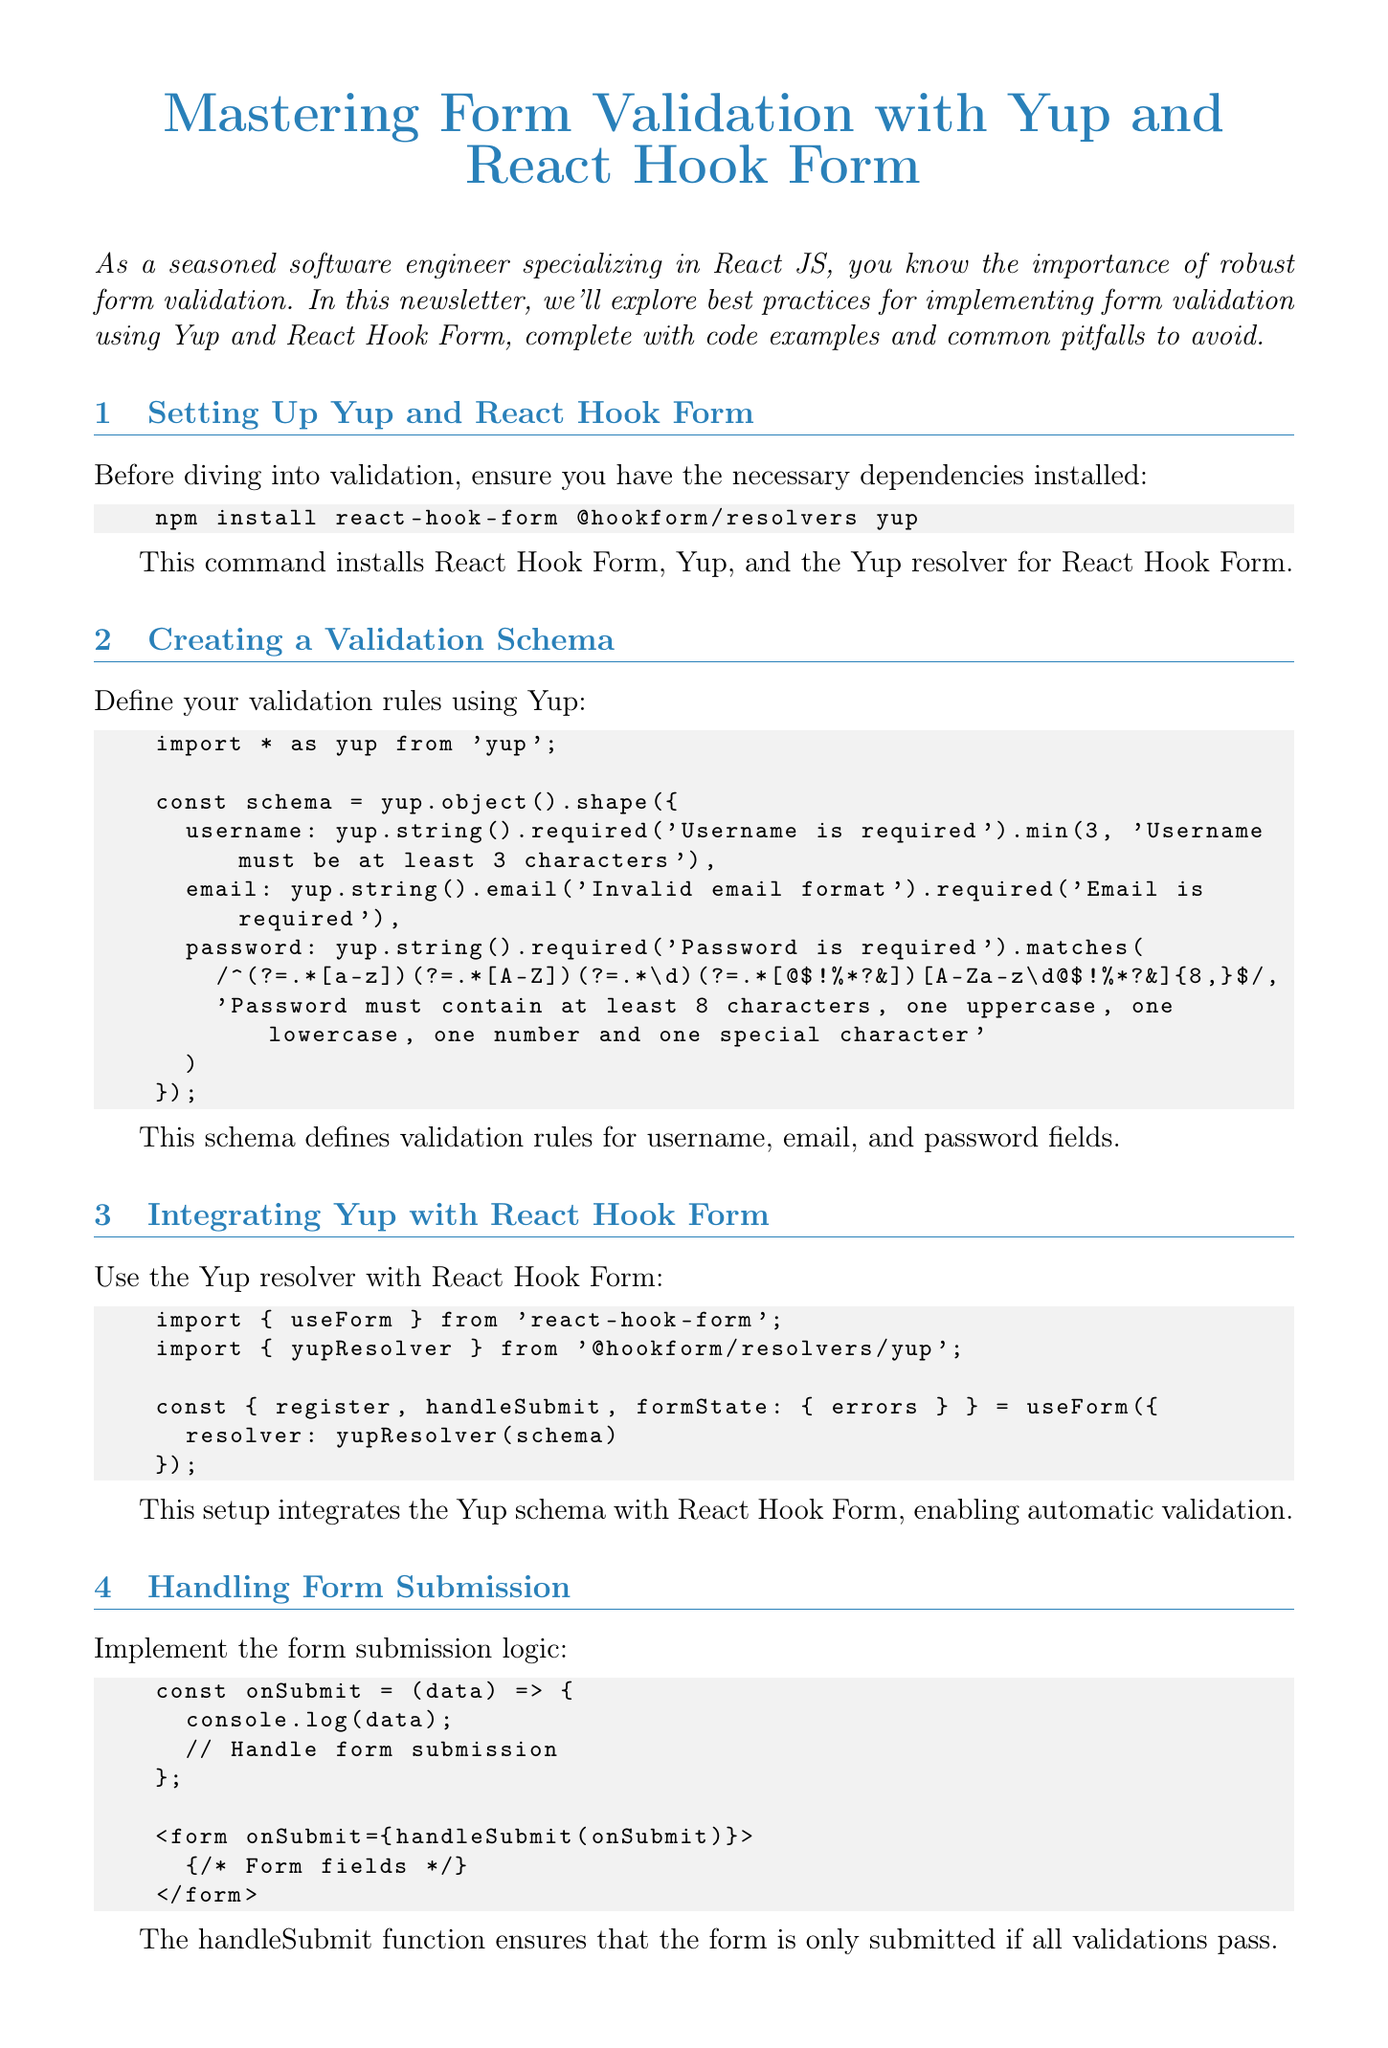What is the title of the newsletter? The title of the newsletter is clearly stated at the beginning of the document.
Answer: Mastering Form Validation with Yup and React Hook Form What is the command to install the dependencies? This command is specified in the section about setting up Yup and React Hook Form.
Answer: npm install react-hook-form @hookform/resolvers yup What are the validation rules for the password? The password validation rules are detailed in the schema created in the document.
Answer: Password must contain at least 8 characters, one uppercase, one lowercase, one number and one special character Which function is used to handle form submission? The document describes the function associated with form submission logic.
Answer: onSubmit What validation mode can improve performance? Recommendations for performance optimization are provided in the corresponding section of the document.
Answer: onBlur What method should be used for conditional validation? The document mentions a method that can be used for conditional validation.
Answer: when How many items are listed in the common pitfalls section? The document presents a bullet point list in the section on common pitfalls and best practices.
Answer: Five What type of validation does the custom async validator check? The document specifies the kind of validation done by the custom async validator in the advanced techniques section.
Answer: Username availability What is the main purpose of the newsletter? The introduction gives a clear statement about the intention of the newsletter.
Answer: Explore best practices for implementing form validation using Yup and React Hook Form 